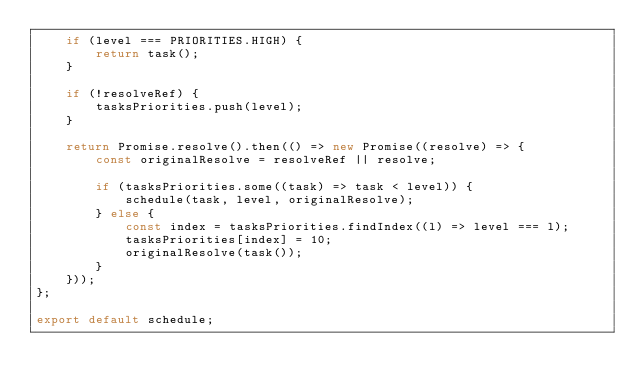Convert code to text. <code><loc_0><loc_0><loc_500><loc_500><_JavaScript_>    if (level === PRIORITIES.HIGH) {
        return task();
    }

    if (!resolveRef) {
        tasksPriorities.push(level);
    }

    return Promise.resolve().then(() => new Promise((resolve) => {
        const originalResolve = resolveRef || resolve;

        if (tasksPriorities.some((task) => task < level)) {
            schedule(task, level, originalResolve);
        } else {
            const index = tasksPriorities.findIndex((l) => level === l);
            tasksPriorities[index] = 10;
            originalResolve(task());
        }
    }));
};

export default schedule;
</code> 